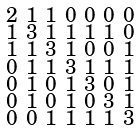<formula> <loc_0><loc_0><loc_500><loc_500>\begin{smallmatrix} 2 & 1 & 1 & 0 & 0 & 0 & 0 \\ 1 & 3 & 1 & 1 & 1 & 1 & 0 \\ 1 & 1 & 3 & 1 & 0 & 0 & 1 \\ 0 & 1 & 1 & 3 & 1 & 1 & 1 \\ 0 & 1 & 0 & 1 & 3 & 0 & 1 \\ 0 & 1 & 0 & 1 & 0 & 3 & 1 \\ 0 & 0 & 1 & 1 & 1 & 1 & 3 \end{smallmatrix}</formula> 